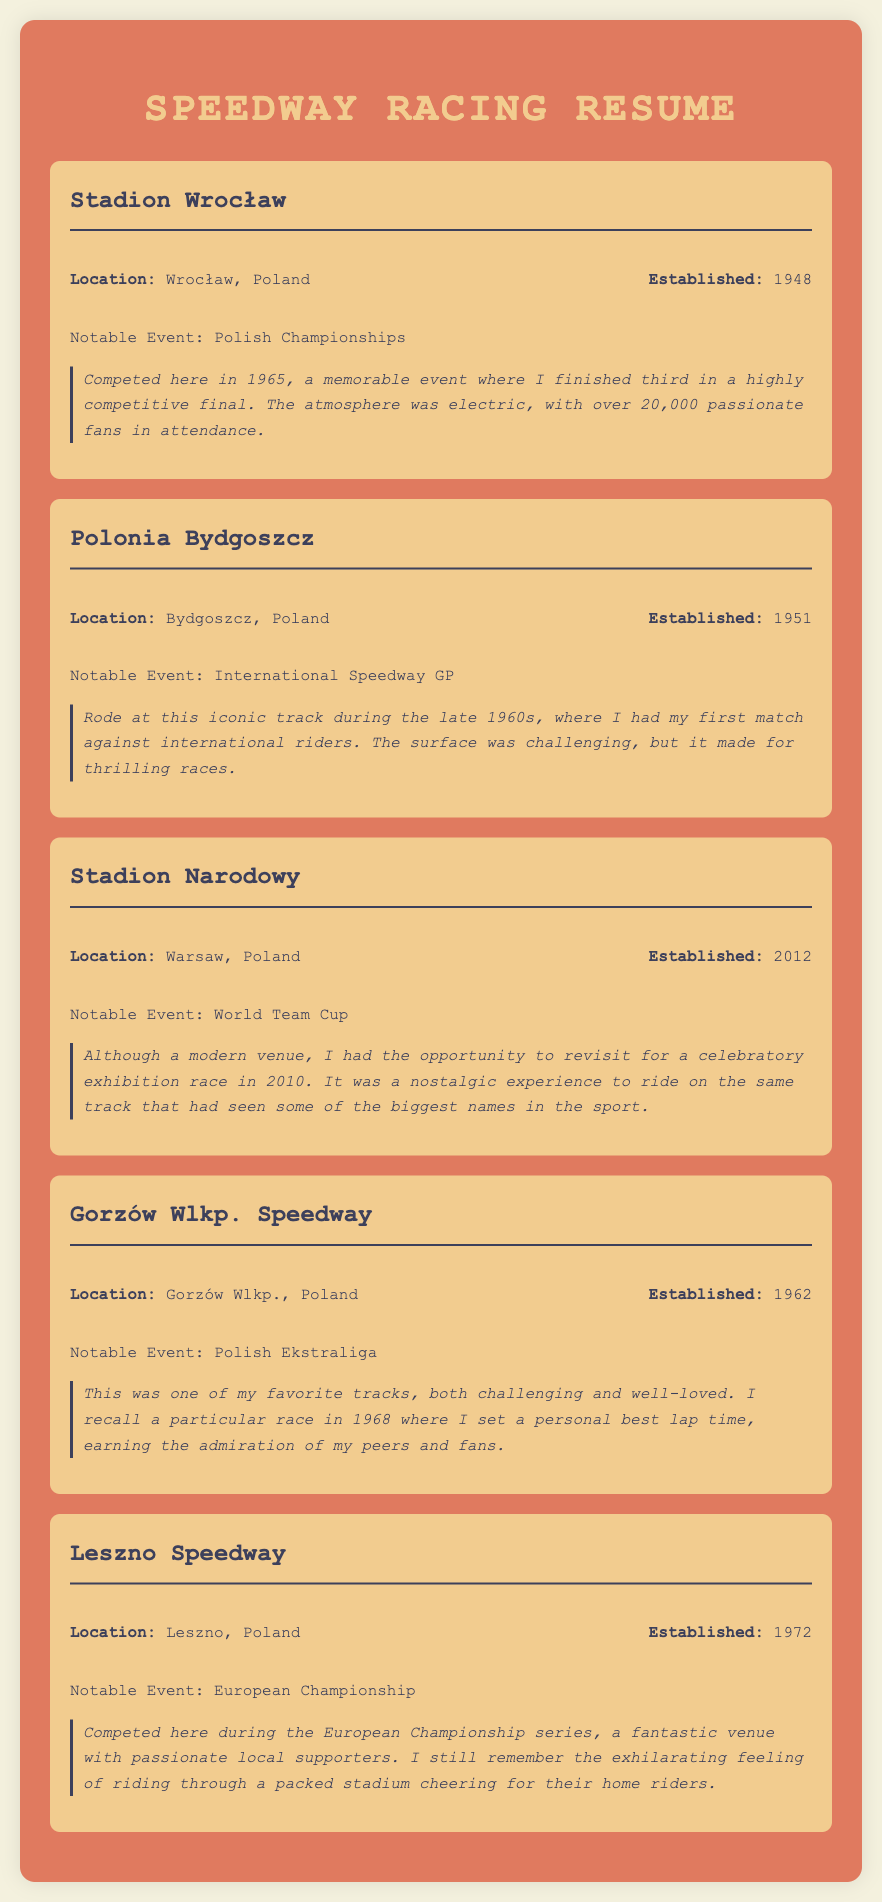what is the location of Stadion Wrocław? The location is provided in the track details section for Stadion Wrocław.
Answer: Wrocław, Poland when was Polonia Bydgoszcz established? The year of establishment for Polonia Bydgoszcz is mentioned in the document.
Answer: 1951 which notable event took place at Stadion Narodowy? The notable event for Stadion Narodowy is specified in the document.
Answer: World Team Cup how many fans attended the Polish Championships event at Stadion Wrocław where the author competed? The document states the attendance at the event held at Stadion Wrocław.
Answer: 20,000 what significant achievement did the author have in Gorzów Wlkp. Speedway in 1968? The document describes a specific accomplishment by the author at Gorzów Wlkp. Speedway.
Answer: Personal best lap time why is Leszno Speedway a memorable venue for the author? The document indicates the author's sentiment regarding competing at Leszno Speedway.
Answer: Passionate local supporters what type of race did the author participate in at Stadion Narodowy in 2010? The document mentions the type of event in which the author participated at Stadion Narodowy in 2010.
Answer: Exhibition race which decade did the author ride at Polonia Bydgoszcz? The timeframe of the author's competitions at Polonia Bydgoszcz is noted in the document.
Answer: Late 1960s 